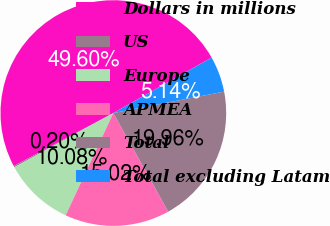Convert chart to OTSL. <chart><loc_0><loc_0><loc_500><loc_500><pie_chart><fcel>Dollars in millions<fcel>US<fcel>Europe<fcel>APMEA<fcel>Total<fcel>Total excluding Latam<nl><fcel>49.6%<fcel>0.2%<fcel>10.08%<fcel>15.02%<fcel>19.96%<fcel>5.14%<nl></chart> 